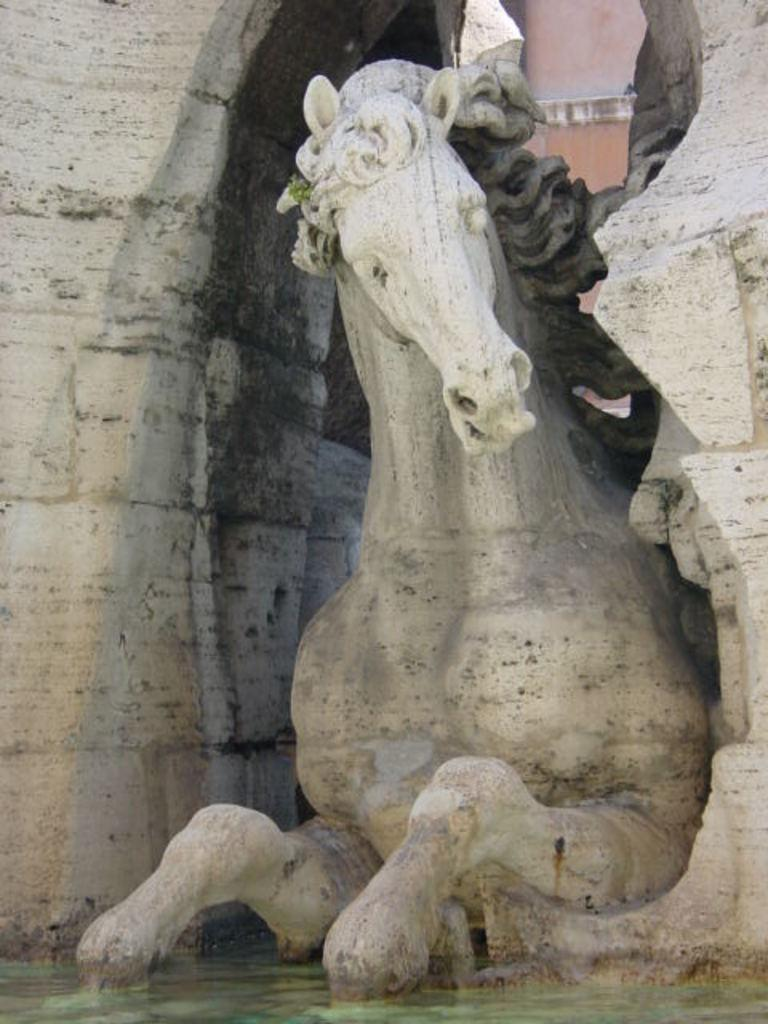What is the main subject in the image? There is a horse sculpture in the image. What can be seen in the front part of the image? There is water visible at the front of the image. What type of tomatoes can be seen being read by the horse sculpture in the image? There are no tomatoes or reading activity present in the image. 